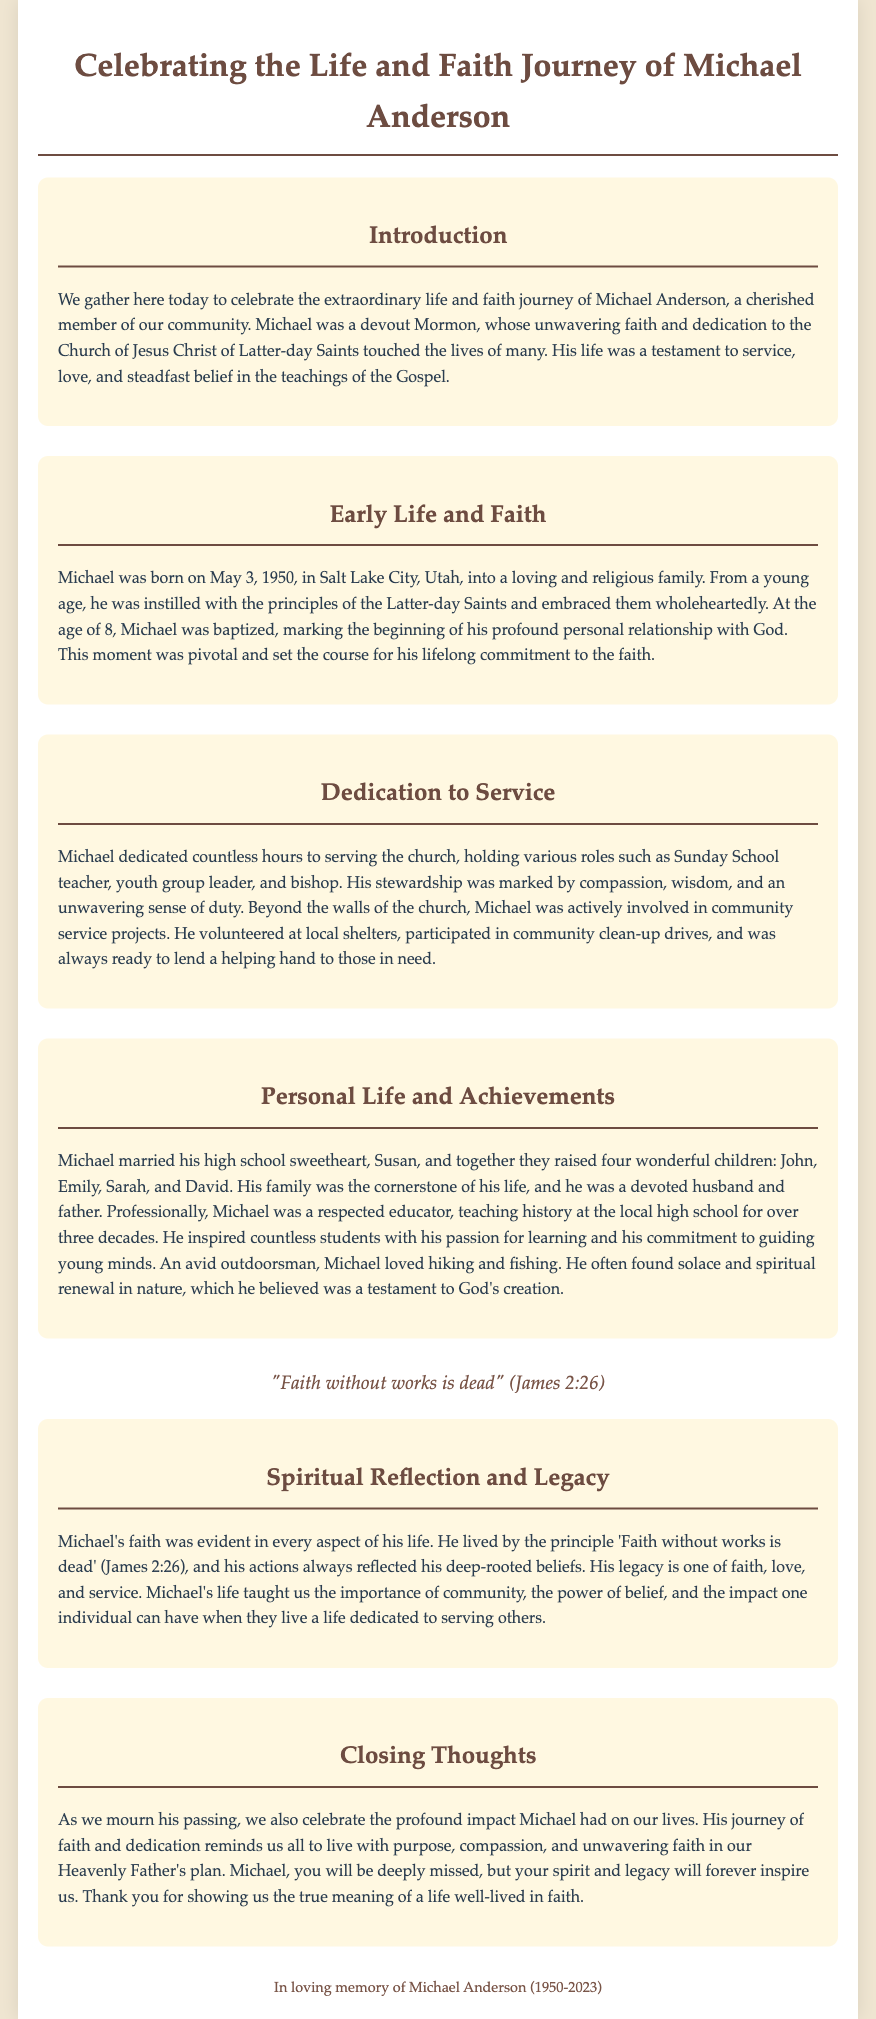What is the full name of the person being honored? The document mentions the full name of the person being honored as Michael Anderson.
Answer: Michael Anderson When was Michael Anderson born? The document states that Michael was born on May 3, 1950.
Answer: May 3, 1950 How many children did Michael Anderson have? The document indicates that Michael raised four children: John, Emily, Sarah, and David.
Answer: Four What biblical verse did Michael live by? The document includes the verse "Faith without works is dead" (James 2:26) that Michael lived by.
Answer: Faith without works is dead What role did Michael Anderson hold in the church? The document specifies that Michael held various roles in the church, including bishop.
Answer: Bishop How did Michael Anderson find solace? The document states that Michael found solace and spiritual renewal in nature.
Answer: Nature What profession did Michael Anderson have? The document indicates that Michael was a respected educator who taught history.
Answer: Educator What did Michael's life teach us? The document emphasizes that Michael's life taught the importance of community and the power of belief.
Answer: Importance of community and power of belief What does the closing paragraph highlight? The closing paragraph highlights the profound impact Michael had on the lives of those around him.
Answer: Profound impact 